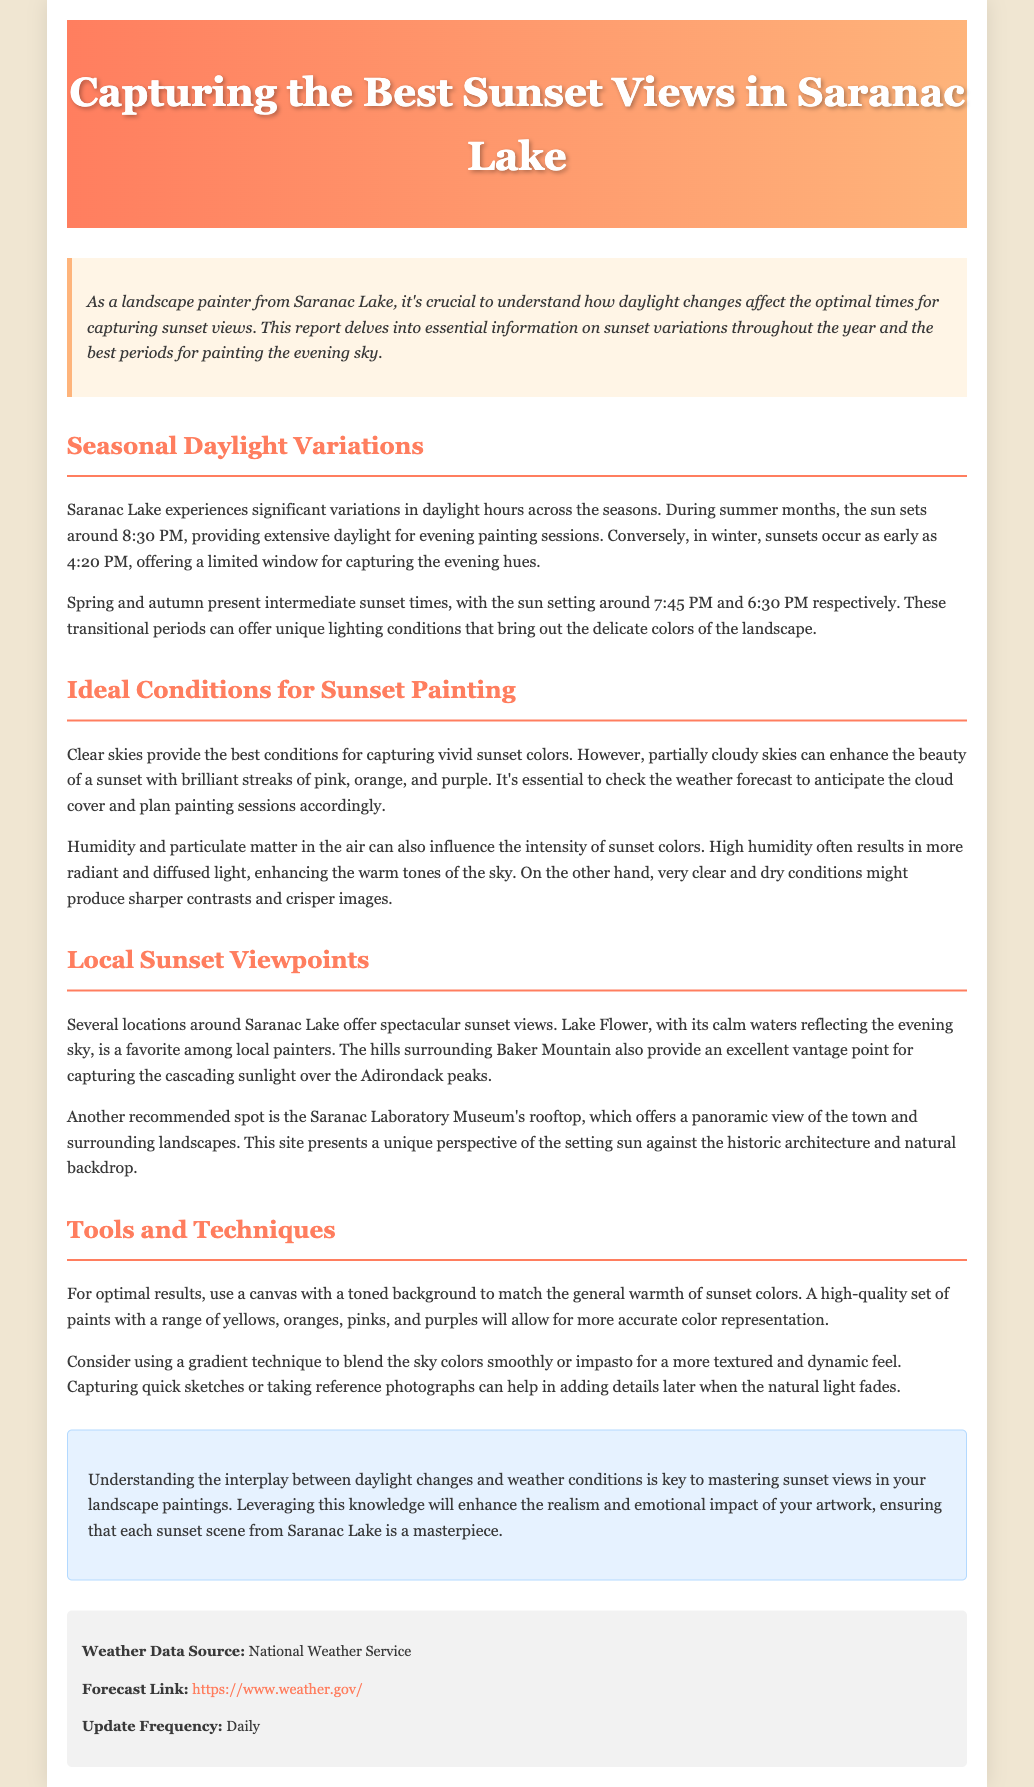What time does the sun set in July? The document states that during summer months, the sun sets around 8:30 PM.
Answer: 8:30 PM What is the earliest sunset time mentioned? The document mentions that in winter, sunsets occur as early as 4:20 PM.
Answer: 4:20 PM What location is noted for calm water reflections? It is mentioned that Lake Flower is favored among local painters for its calm waters reflecting the evening sky.
Answer: Lake Flower Which viewpoint offers a panoramic view of the town? The document points out that the Saranac Laboratory Museum's rooftop provides a panoramic view.
Answer: Saranac Laboratory Museum's rooftop What is the ideal condition for capturing vivid sunset colors? The document indicates that clear skies provide the best conditions for capturing vivid sunset colors.
Answer: Clear skies In which season is the sun said to set around 6:30 PM? The document states that the sun sets around 6:30 PM during autumn.
Answer: Autumn What technique is suggested for blending sky colors smoothly? The document recommends using a gradient technique for blending sky colors smoothly.
Answer: Gradient technique What is the weather data source mentioned? The document states that the weather data source is the National Weather Service.
Answer: National Weather Service What colors are recommended for sunset painting? The document suggests using a range of yellows, oranges, pinks, and purples for sunset painting.
Answer: Yellows, oranges, pinks, and purples 